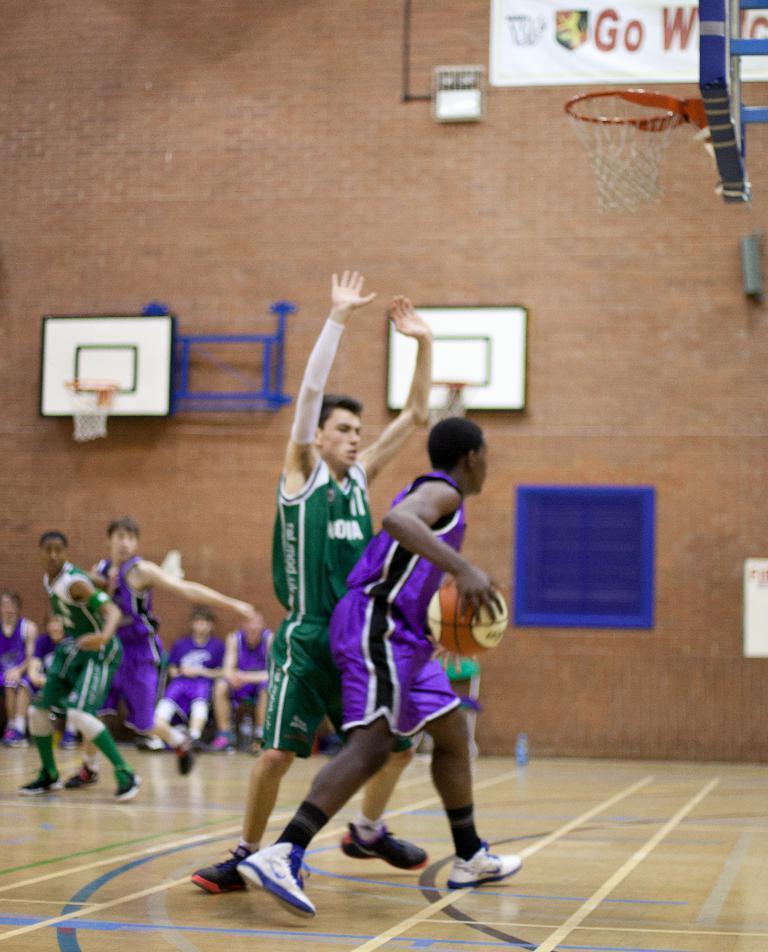Please provide a concise description of this image. In the image there are few players on the court. In the front of the image there is a man holding a ball in the hand. In the top right corner of the image there is a board with basket. Behind them there are few people sitting. And in the background there is a wall with window, boards with baskets and also there is a banner with some text on it. 